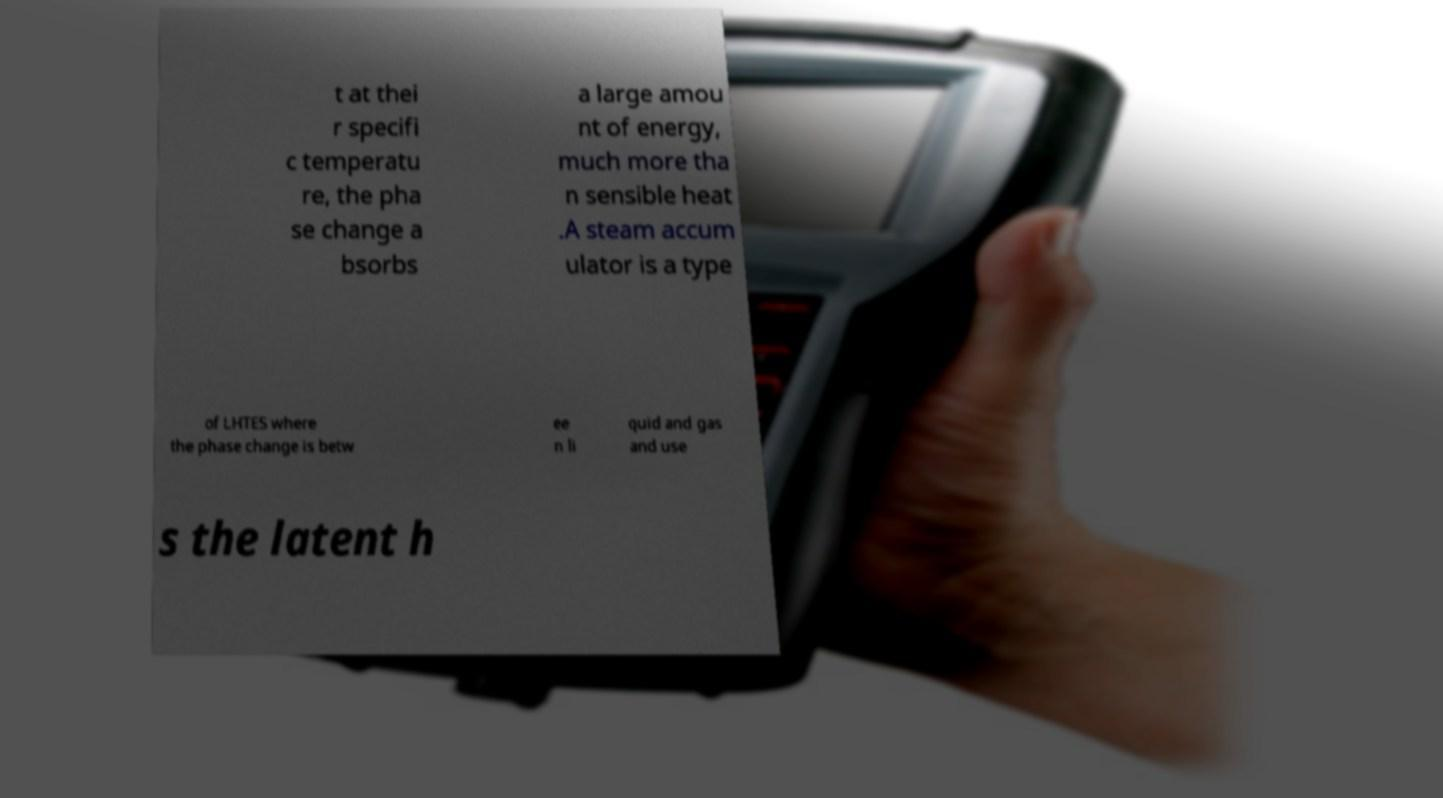Can you accurately transcribe the text from the provided image for me? t at thei r specifi c temperatu re, the pha se change a bsorbs a large amou nt of energy, much more tha n sensible heat .A steam accum ulator is a type of LHTES where the phase change is betw ee n li quid and gas and use s the latent h 